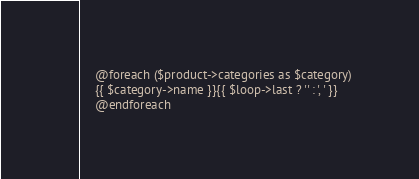Convert code to text. <code><loc_0><loc_0><loc_500><loc_500><_PHP_>
    @foreach ($product->categories as $category)
    {{ $category->name }}{{ $loop->last ? '' : ', ' }}
    @endforeach

</code> 